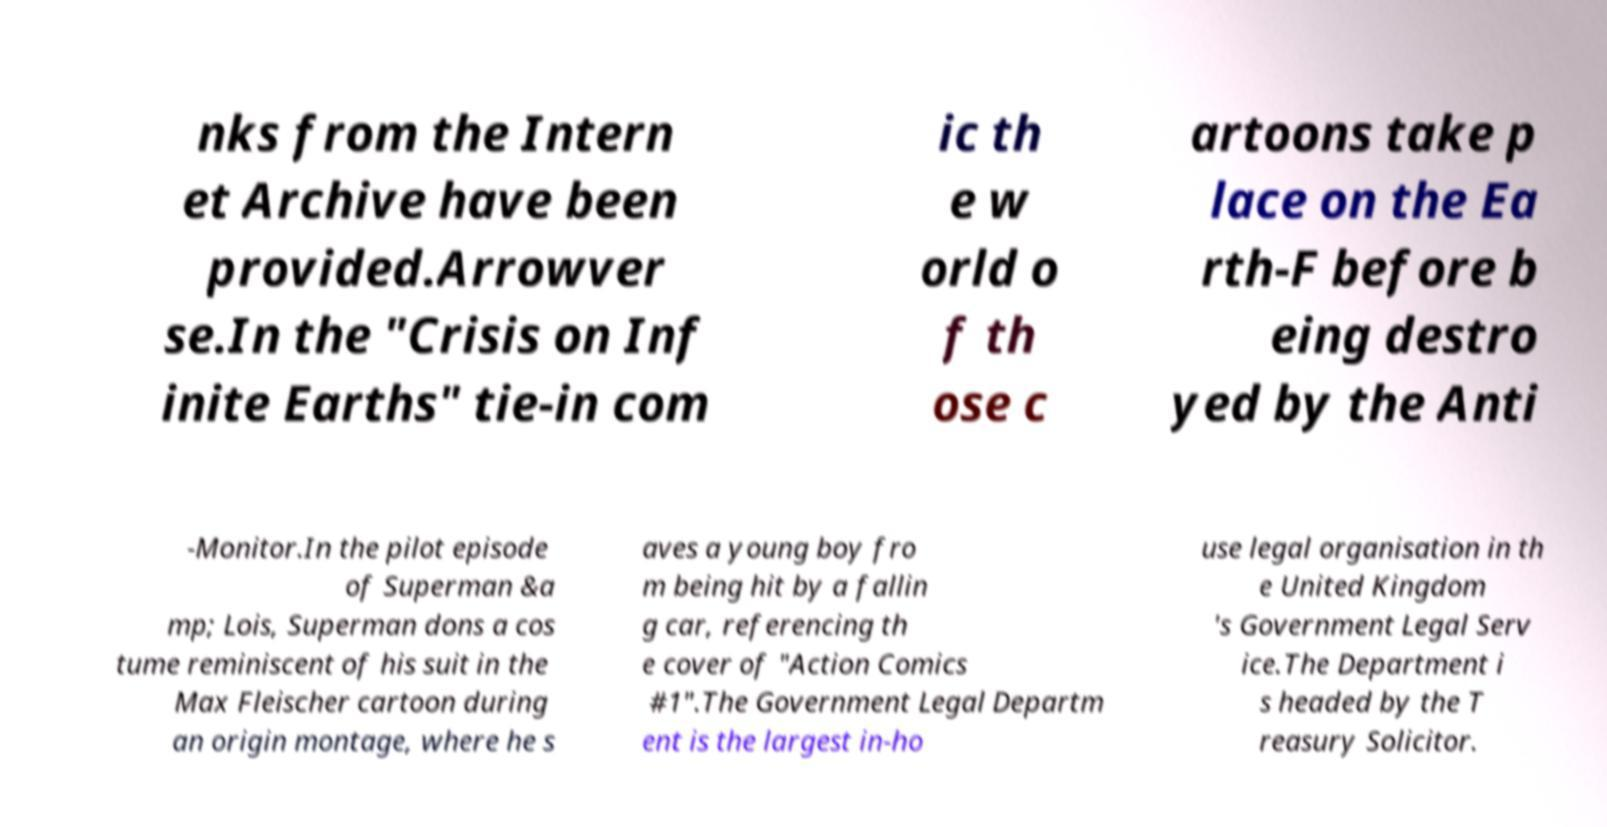I need the written content from this picture converted into text. Can you do that? nks from the Intern et Archive have been provided.Arrowver se.In the "Crisis on Inf inite Earths" tie-in com ic th e w orld o f th ose c artoons take p lace on the Ea rth-F before b eing destro yed by the Anti -Monitor.In the pilot episode of Superman &a mp; Lois, Superman dons a cos tume reminiscent of his suit in the Max Fleischer cartoon during an origin montage, where he s aves a young boy fro m being hit by a fallin g car, referencing th e cover of "Action Comics #1".The Government Legal Departm ent is the largest in-ho use legal organisation in th e United Kingdom 's Government Legal Serv ice.The Department i s headed by the T reasury Solicitor. 